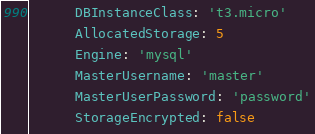Convert code to text. <code><loc_0><loc_0><loc_500><loc_500><_YAML_>      DBInstanceClass: 't3.micro'
      AllocatedStorage: 5
      Engine: 'mysql'
      MasterUsername: 'master'
      MasterUserPassword: 'password'
      StorageEncrypted: false
</code> 